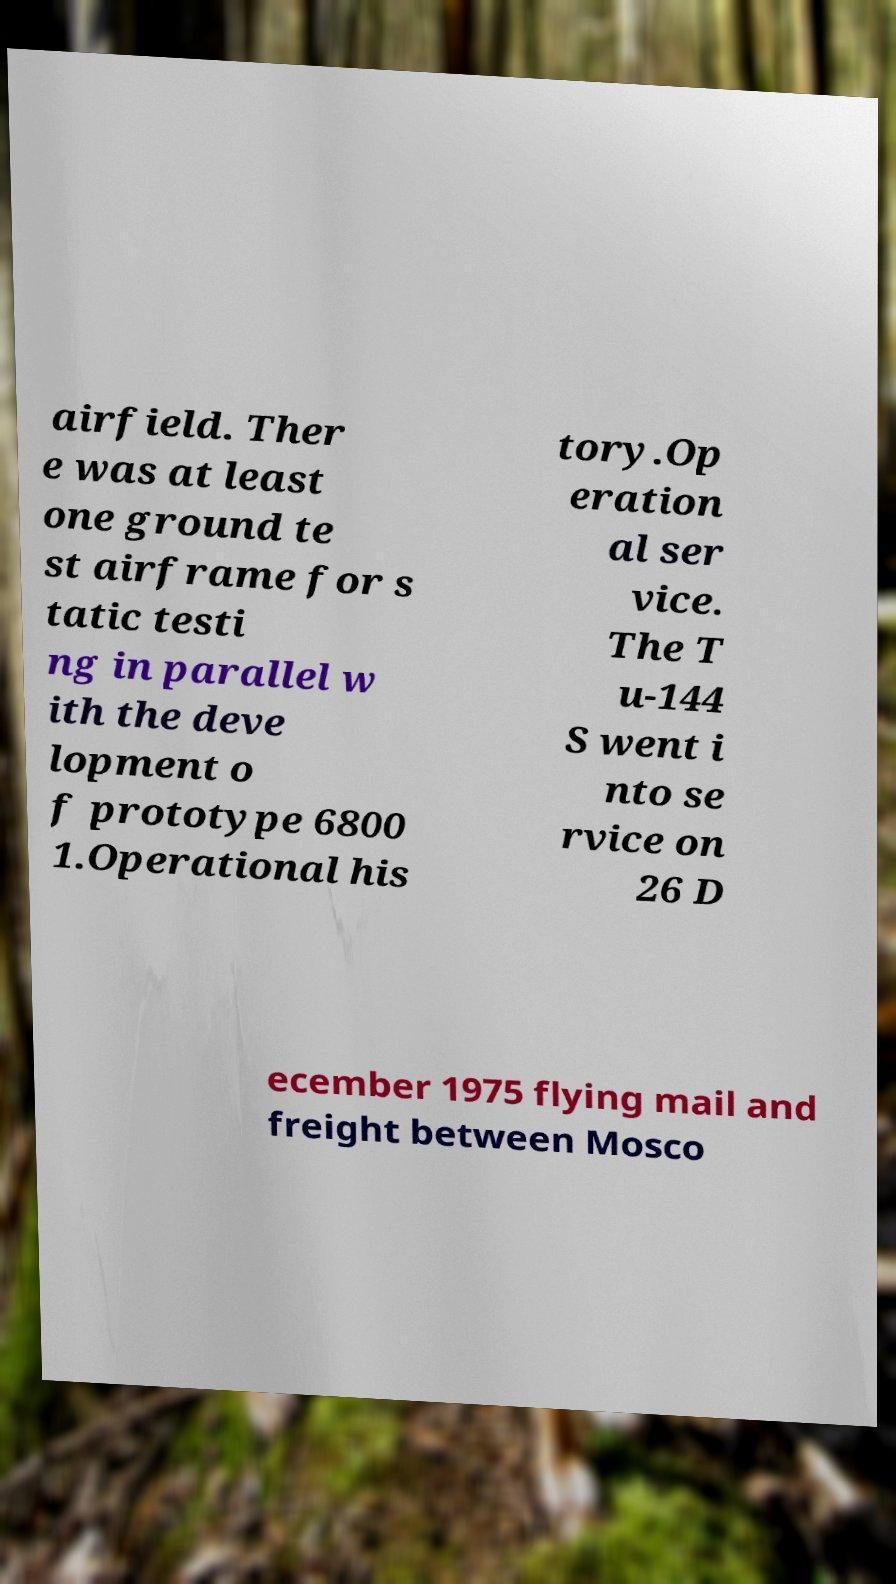For documentation purposes, I need the text within this image transcribed. Could you provide that? airfield. Ther e was at least one ground te st airframe for s tatic testi ng in parallel w ith the deve lopment o f prototype 6800 1.Operational his tory.Op eration al ser vice. The T u-144 S went i nto se rvice on 26 D ecember 1975 flying mail and freight between Mosco 